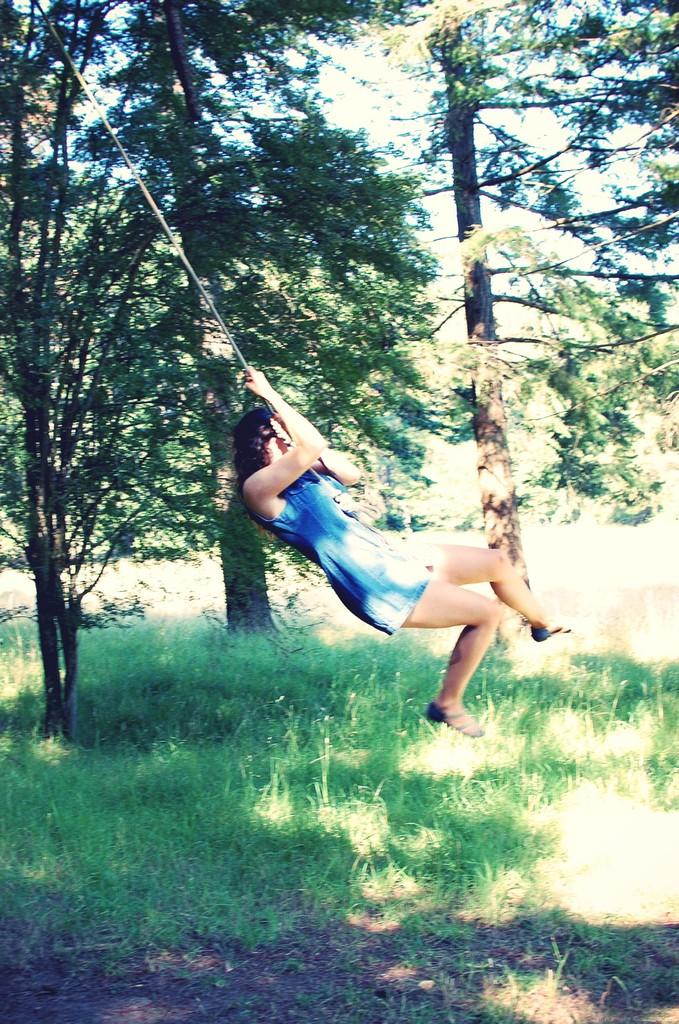Who is the main subject in the image? There is a girl in the image. What is the girl wearing? The girl is wearing a dress. What is the girl holding in her hands? The girl is holding a rope in her hands. What can be seen in the background of the image? There is a group of trees and the sky visible in the background of the image. What grade does the girl receive for her performance in the image? There is no indication of a performance or grading system in the image, so it cannot be determined. 